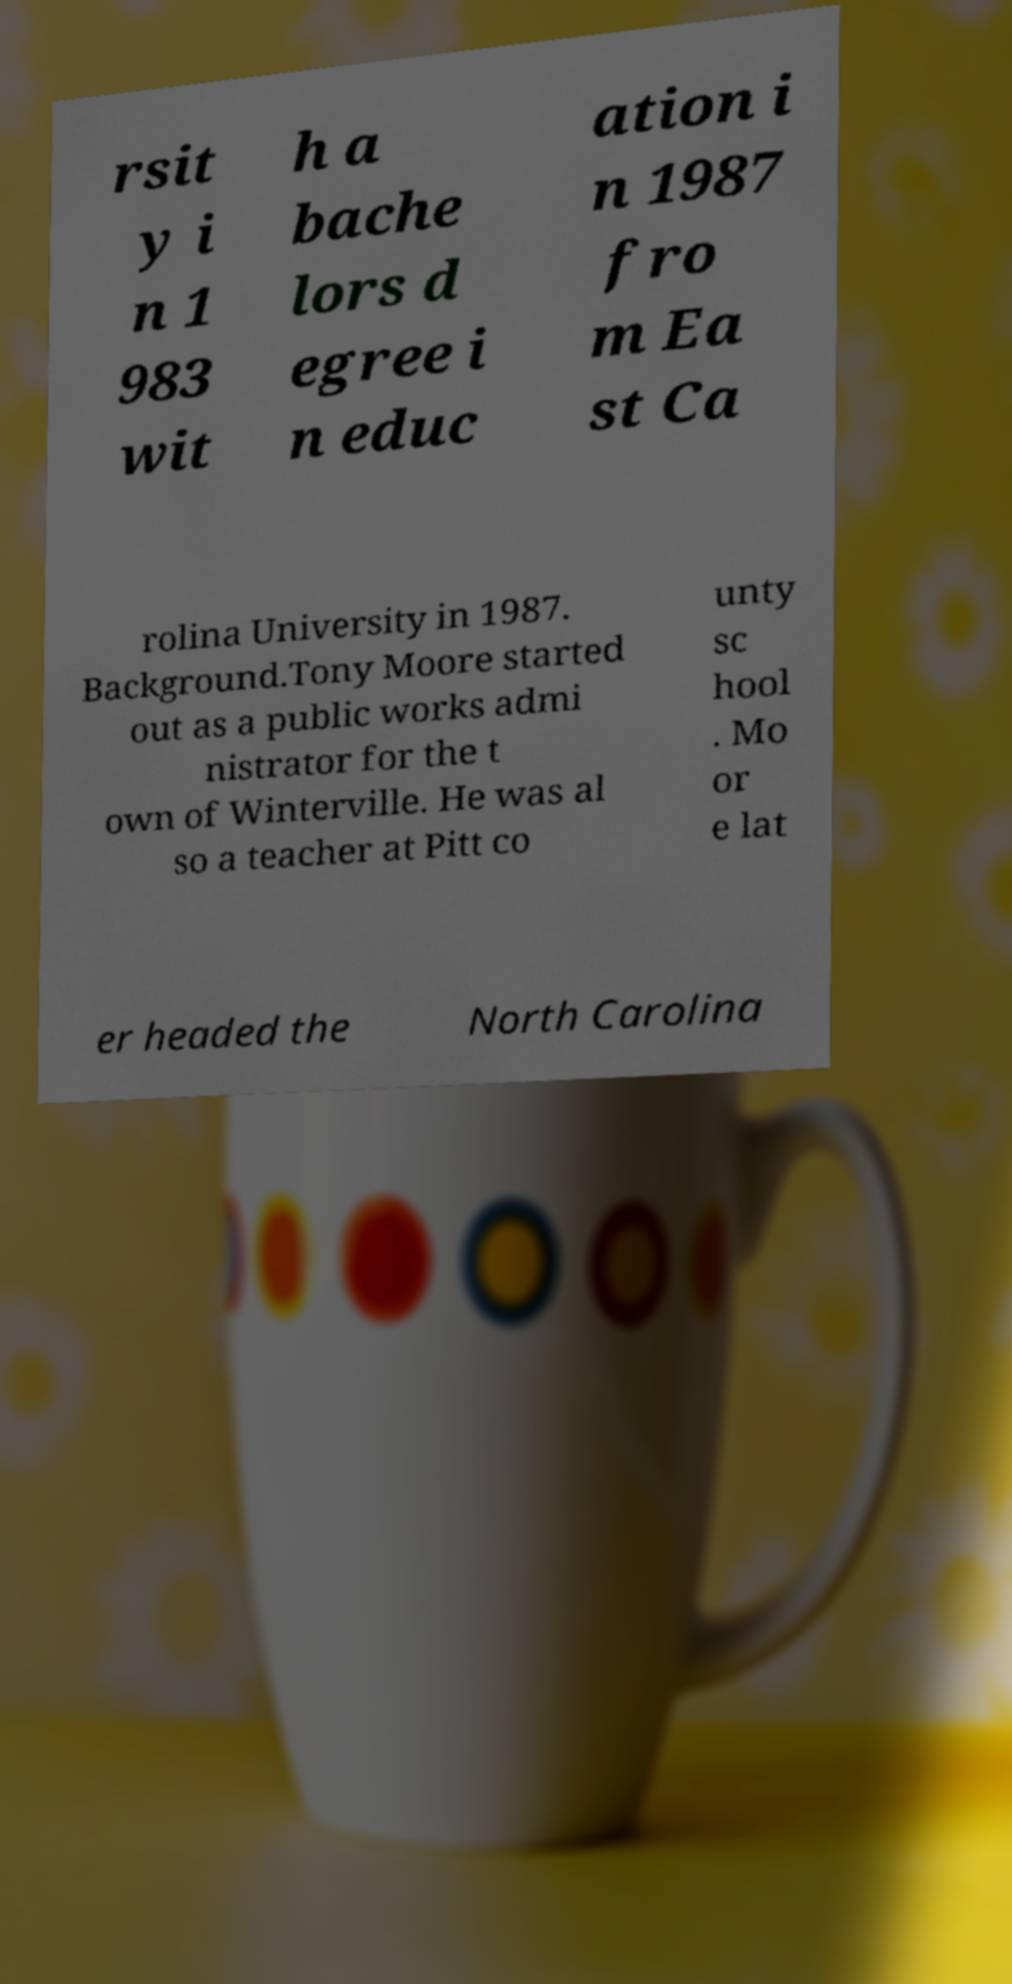What messages or text are displayed in this image? I need them in a readable, typed format. rsit y i n 1 983 wit h a bache lors d egree i n educ ation i n 1987 fro m Ea st Ca rolina University in 1987. Background.Tony Moore started out as a public works admi nistrator for the t own of Winterville. He was al so a teacher at Pitt co unty sc hool . Mo or e lat er headed the North Carolina 